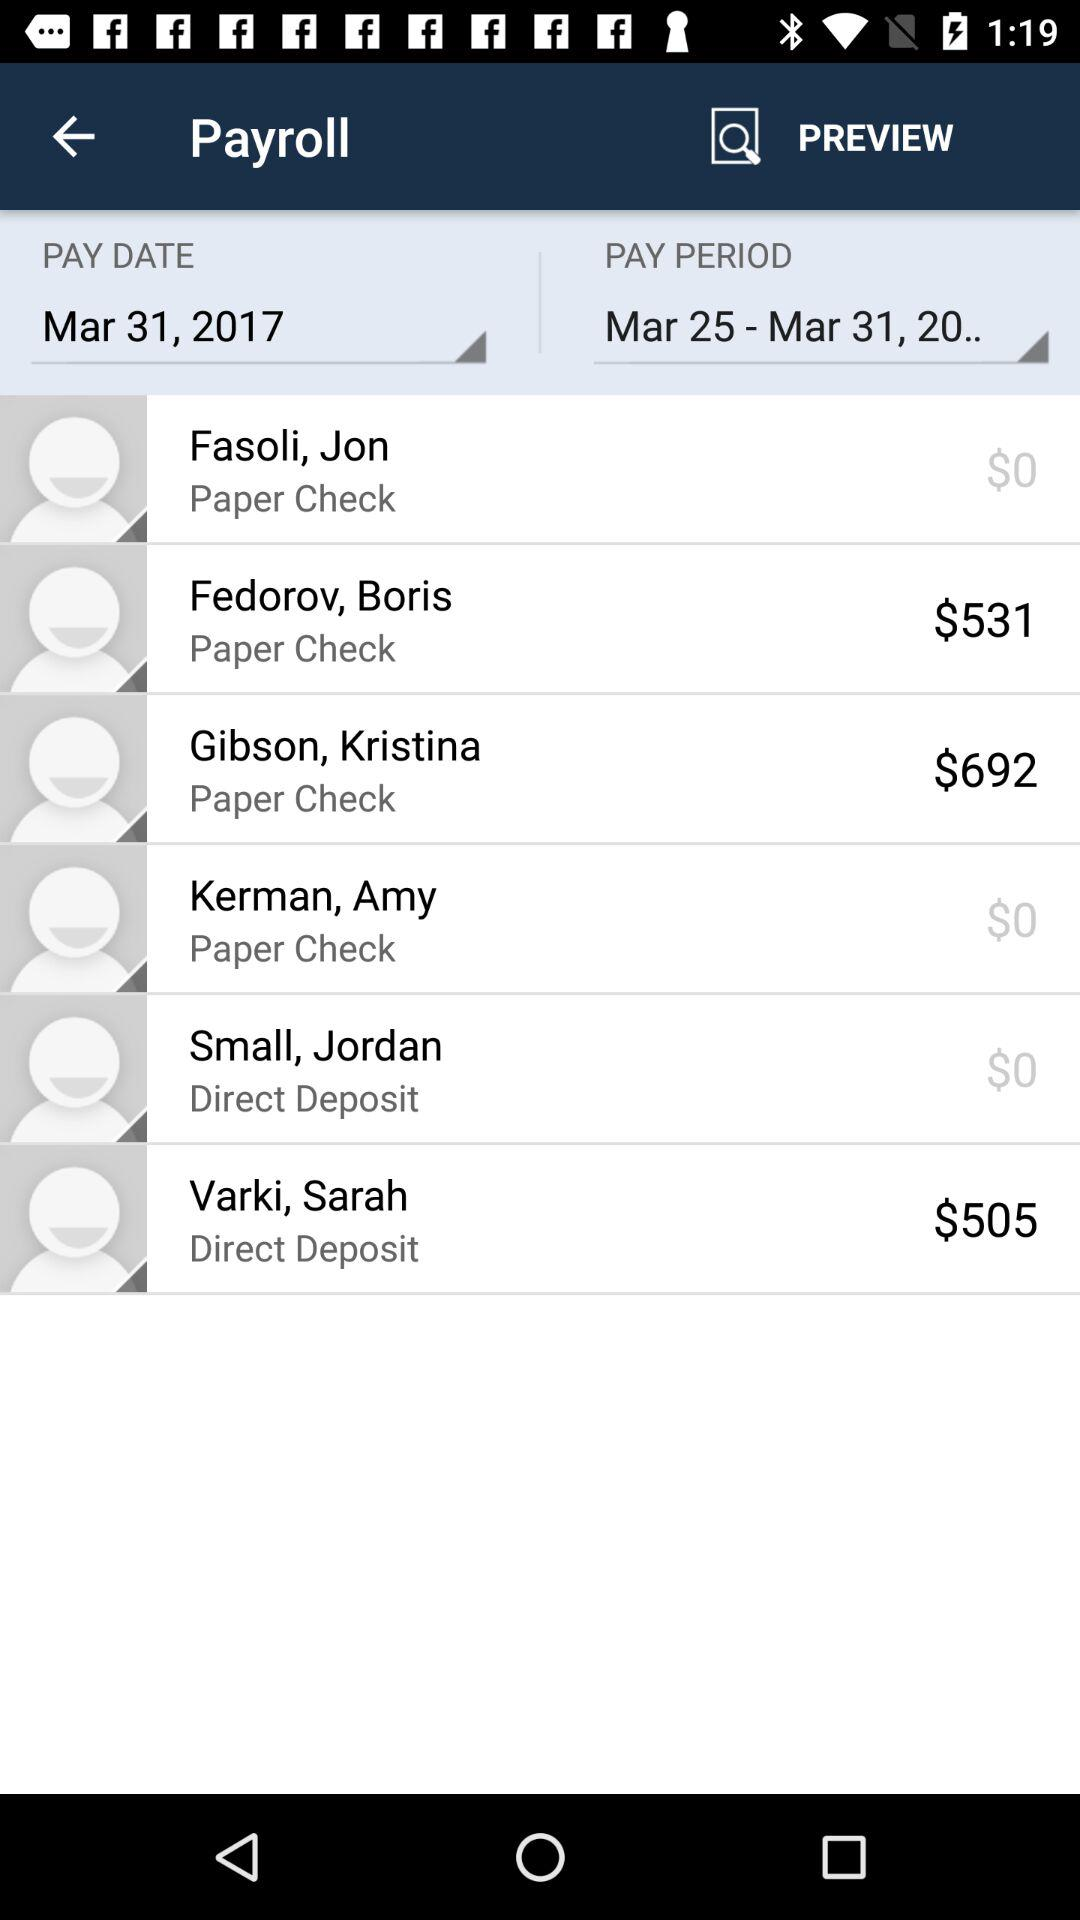What is the pay date? The pay date is March 31, 2017. 